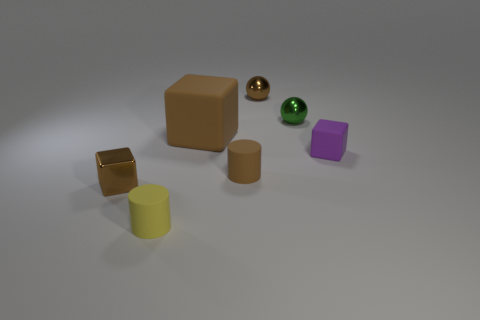Add 1 tiny brown rubber objects. How many objects exist? 8 Subtract all cylinders. How many objects are left? 5 Add 5 large things. How many large things exist? 6 Subtract 0 red blocks. How many objects are left? 7 Subtract all shiny spheres. Subtract all large rubber blocks. How many objects are left? 4 Add 4 tiny rubber cylinders. How many tiny rubber cylinders are left? 6 